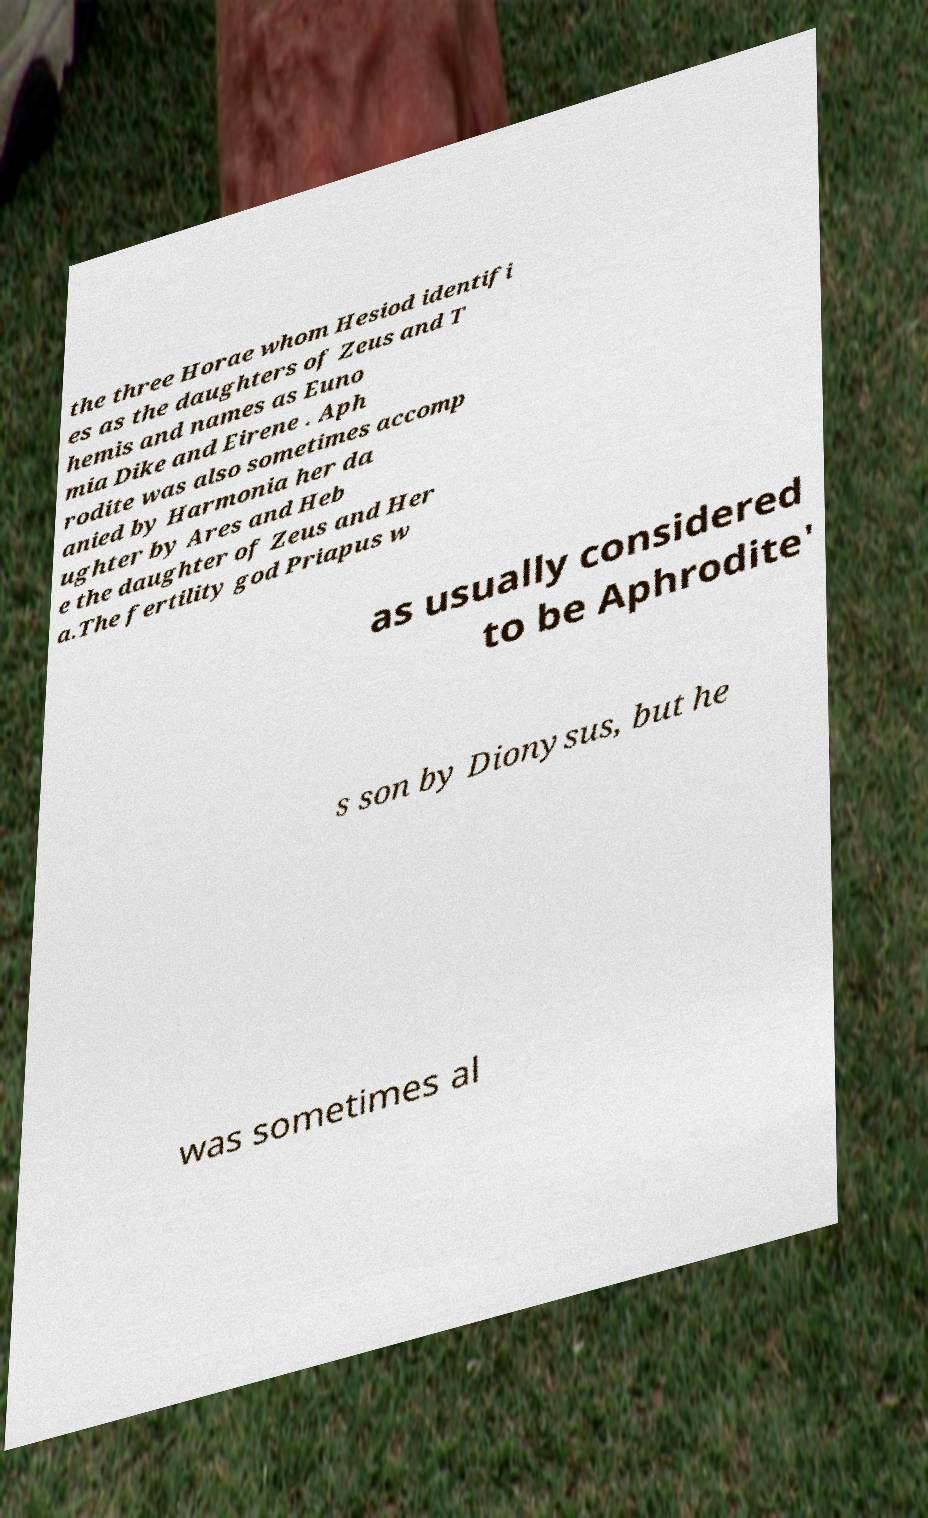There's text embedded in this image that I need extracted. Can you transcribe it verbatim? the three Horae whom Hesiod identifi es as the daughters of Zeus and T hemis and names as Euno mia Dike and Eirene . Aph rodite was also sometimes accomp anied by Harmonia her da ughter by Ares and Heb e the daughter of Zeus and Her a.The fertility god Priapus w as usually considered to be Aphrodite' s son by Dionysus, but he was sometimes al 